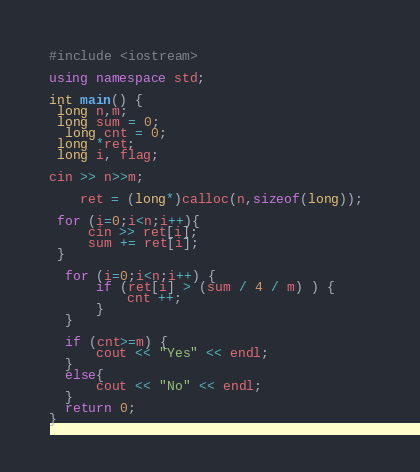<code> <loc_0><loc_0><loc_500><loc_500><_C++_>#include <iostream>

using namespace std;

int main() {
 long n,m;
 long sum = 0;
  long cnt = 0;
 long *ret;
 long i, flag;

cin >> n>>m;
    
    ret = (long*)calloc(n,sizeof(long)); 

 for (i=0;i<n;i++){
     cin >> ret[i];
     sum += ret[i];
 }
  
  for (i=0;i<n;i++) {
      if (ret[i] > (sum / 4 / m) ) {
          cnt ++;
      }
  }

  if (cnt>=m) {
      cout << "Yes" << endl;
  }
  else{
      cout << "No" << endl;
  }
  return 0;
}</code> 